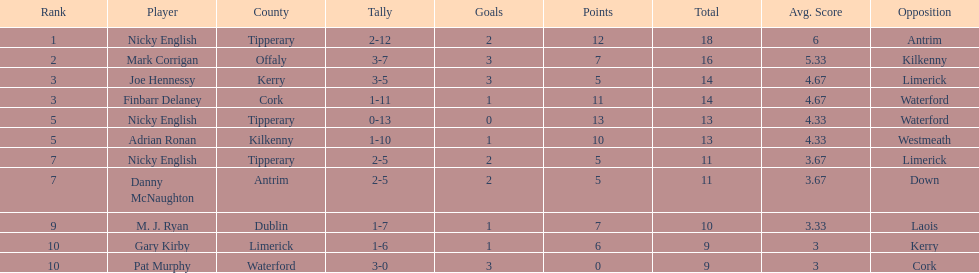Who ranked above mark corrigan? Nicky English. 